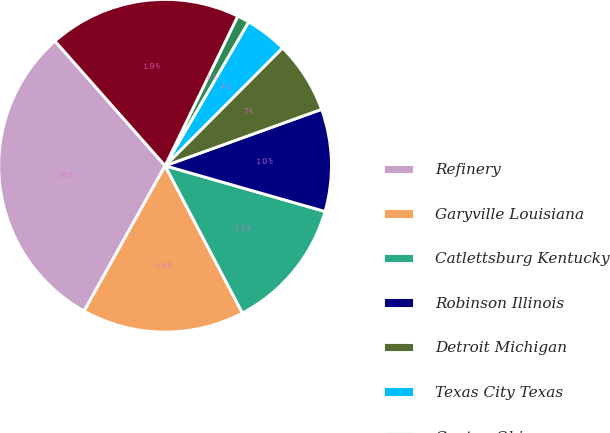Convert chart to OTSL. <chart><loc_0><loc_0><loc_500><loc_500><pie_chart><fcel>Refinery<fcel>Garyville Louisiana<fcel>Catlettsburg Kentucky<fcel>Robinson Illinois<fcel>Detroit Michigan<fcel>Texas City Texas<fcel>Canton Ohio<fcel>Total<nl><fcel>30.39%<fcel>15.79%<fcel>12.87%<fcel>9.94%<fcel>7.02%<fcel>4.1%<fcel>1.18%<fcel>18.71%<nl></chart> 